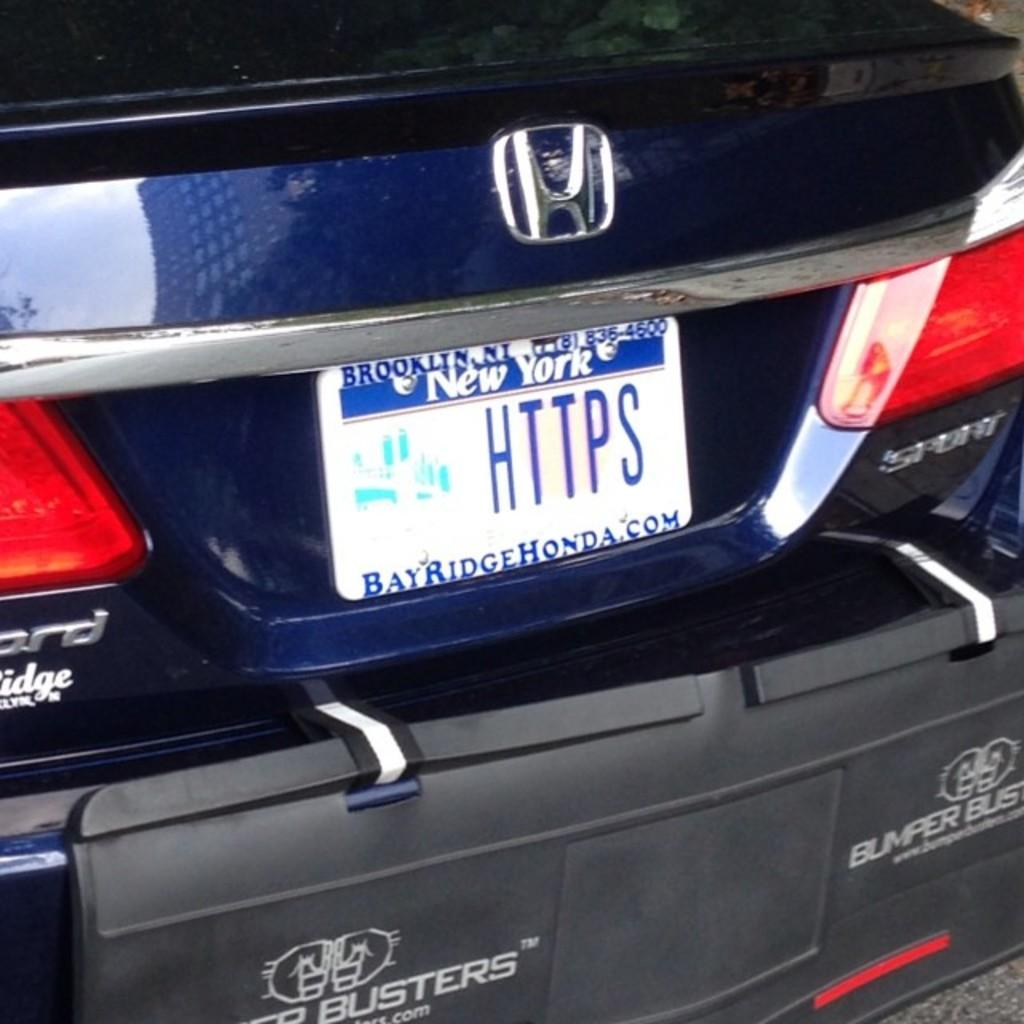<image>
Write a terse but informative summary of the picture. honda from bay ridge honda with new york tags HTTPS 